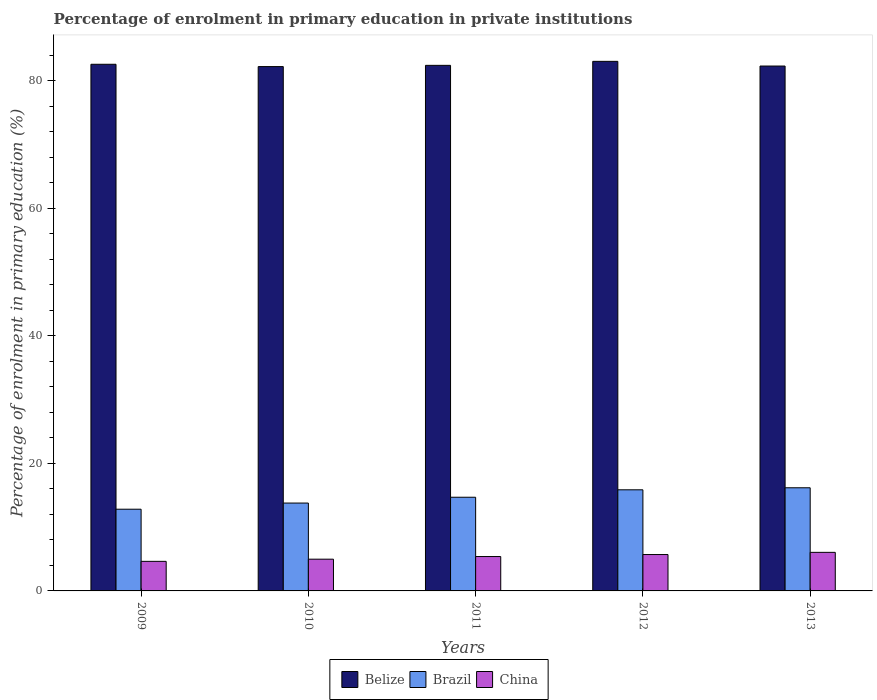How many different coloured bars are there?
Keep it short and to the point. 3. How many bars are there on the 5th tick from the right?
Make the answer very short. 3. In how many cases, is the number of bars for a given year not equal to the number of legend labels?
Ensure brevity in your answer.  0. What is the percentage of enrolment in primary education in Brazil in 2013?
Offer a terse response. 16.17. Across all years, what is the maximum percentage of enrolment in primary education in Brazil?
Your answer should be compact. 16.17. Across all years, what is the minimum percentage of enrolment in primary education in Brazil?
Your answer should be very brief. 12.81. In which year was the percentage of enrolment in primary education in China maximum?
Keep it short and to the point. 2013. In which year was the percentage of enrolment in primary education in Belize minimum?
Your response must be concise. 2010. What is the total percentage of enrolment in primary education in Belize in the graph?
Your response must be concise. 412.55. What is the difference between the percentage of enrolment in primary education in China in 2011 and that in 2013?
Offer a very short reply. -0.65. What is the difference between the percentage of enrolment in primary education in China in 2010 and the percentage of enrolment in primary education in Brazil in 2013?
Your response must be concise. -11.2. What is the average percentage of enrolment in primary education in China per year?
Your response must be concise. 5.35. In the year 2012, what is the difference between the percentage of enrolment in primary education in Brazil and percentage of enrolment in primary education in Belize?
Offer a terse response. -67.18. In how many years, is the percentage of enrolment in primary education in China greater than 32 %?
Offer a terse response. 0. What is the ratio of the percentage of enrolment in primary education in China in 2009 to that in 2011?
Make the answer very short. 0.86. What is the difference between the highest and the second highest percentage of enrolment in primary education in Brazil?
Keep it short and to the point. 0.32. What is the difference between the highest and the lowest percentage of enrolment in primary education in China?
Provide a succinct answer. 1.41. In how many years, is the percentage of enrolment in primary education in China greater than the average percentage of enrolment in primary education in China taken over all years?
Ensure brevity in your answer.  3. Is the sum of the percentage of enrolment in primary education in Brazil in 2009 and 2012 greater than the maximum percentage of enrolment in primary education in China across all years?
Provide a succinct answer. Yes. What does the 1st bar from the left in 2009 represents?
Provide a short and direct response. Belize. What does the 2nd bar from the right in 2013 represents?
Your answer should be very brief. Brazil. Are all the bars in the graph horizontal?
Offer a very short reply. No. What is the difference between two consecutive major ticks on the Y-axis?
Your answer should be compact. 20. Are the values on the major ticks of Y-axis written in scientific E-notation?
Ensure brevity in your answer.  No. Does the graph contain any zero values?
Your response must be concise. No. Does the graph contain grids?
Your response must be concise. No. Where does the legend appear in the graph?
Offer a terse response. Bottom center. What is the title of the graph?
Your answer should be very brief. Percentage of enrolment in primary education in private institutions. What is the label or title of the Y-axis?
Provide a short and direct response. Percentage of enrolment in primary education (%). What is the Percentage of enrolment in primary education (%) in Belize in 2009?
Your answer should be very brief. 82.58. What is the Percentage of enrolment in primary education (%) in Brazil in 2009?
Ensure brevity in your answer.  12.81. What is the Percentage of enrolment in primary education (%) in China in 2009?
Give a very brief answer. 4.64. What is the Percentage of enrolment in primary education (%) of Belize in 2010?
Give a very brief answer. 82.22. What is the Percentage of enrolment in primary education (%) of Brazil in 2010?
Offer a terse response. 13.78. What is the Percentage of enrolment in primary education (%) in China in 2010?
Provide a succinct answer. 4.98. What is the Percentage of enrolment in primary education (%) of Belize in 2011?
Ensure brevity in your answer.  82.41. What is the Percentage of enrolment in primary education (%) in Brazil in 2011?
Offer a terse response. 14.69. What is the Percentage of enrolment in primary education (%) in China in 2011?
Offer a very short reply. 5.39. What is the Percentage of enrolment in primary education (%) of Belize in 2012?
Give a very brief answer. 83.04. What is the Percentage of enrolment in primary education (%) of Brazil in 2012?
Make the answer very short. 15.86. What is the Percentage of enrolment in primary education (%) of China in 2012?
Ensure brevity in your answer.  5.7. What is the Percentage of enrolment in primary education (%) of Belize in 2013?
Offer a terse response. 82.3. What is the Percentage of enrolment in primary education (%) of Brazil in 2013?
Ensure brevity in your answer.  16.17. What is the Percentage of enrolment in primary education (%) of China in 2013?
Your response must be concise. 6.05. Across all years, what is the maximum Percentage of enrolment in primary education (%) in Belize?
Give a very brief answer. 83.04. Across all years, what is the maximum Percentage of enrolment in primary education (%) of Brazil?
Provide a short and direct response. 16.17. Across all years, what is the maximum Percentage of enrolment in primary education (%) of China?
Give a very brief answer. 6.05. Across all years, what is the minimum Percentage of enrolment in primary education (%) in Belize?
Offer a very short reply. 82.22. Across all years, what is the minimum Percentage of enrolment in primary education (%) of Brazil?
Keep it short and to the point. 12.81. Across all years, what is the minimum Percentage of enrolment in primary education (%) of China?
Give a very brief answer. 4.64. What is the total Percentage of enrolment in primary education (%) in Belize in the graph?
Provide a succinct answer. 412.55. What is the total Percentage of enrolment in primary education (%) of Brazil in the graph?
Your answer should be compact. 73.31. What is the total Percentage of enrolment in primary education (%) of China in the graph?
Offer a very short reply. 26.76. What is the difference between the Percentage of enrolment in primary education (%) in Belize in 2009 and that in 2010?
Your answer should be compact. 0.36. What is the difference between the Percentage of enrolment in primary education (%) of Brazil in 2009 and that in 2010?
Give a very brief answer. -0.97. What is the difference between the Percentage of enrolment in primary education (%) in China in 2009 and that in 2010?
Offer a terse response. -0.34. What is the difference between the Percentage of enrolment in primary education (%) in Belize in 2009 and that in 2011?
Offer a terse response. 0.17. What is the difference between the Percentage of enrolment in primary education (%) of Brazil in 2009 and that in 2011?
Provide a succinct answer. -1.88. What is the difference between the Percentage of enrolment in primary education (%) of China in 2009 and that in 2011?
Offer a terse response. -0.76. What is the difference between the Percentage of enrolment in primary education (%) in Belize in 2009 and that in 2012?
Offer a very short reply. -0.46. What is the difference between the Percentage of enrolment in primary education (%) in Brazil in 2009 and that in 2012?
Your answer should be compact. -3.04. What is the difference between the Percentage of enrolment in primary education (%) in China in 2009 and that in 2012?
Make the answer very short. -1.07. What is the difference between the Percentage of enrolment in primary education (%) of Belize in 2009 and that in 2013?
Make the answer very short. 0.28. What is the difference between the Percentage of enrolment in primary education (%) of Brazil in 2009 and that in 2013?
Offer a very short reply. -3.36. What is the difference between the Percentage of enrolment in primary education (%) of China in 2009 and that in 2013?
Ensure brevity in your answer.  -1.41. What is the difference between the Percentage of enrolment in primary education (%) in Belize in 2010 and that in 2011?
Your response must be concise. -0.19. What is the difference between the Percentage of enrolment in primary education (%) in Brazil in 2010 and that in 2011?
Offer a terse response. -0.91. What is the difference between the Percentage of enrolment in primary education (%) in China in 2010 and that in 2011?
Provide a succinct answer. -0.41. What is the difference between the Percentage of enrolment in primary education (%) in Belize in 2010 and that in 2012?
Give a very brief answer. -0.82. What is the difference between the Percentage of enrolment in primary education (%) in Brazil in 2010 and that in 2012?
Give a very brief answer. -2.08. What is the difference between the Percentage of enrolment in primary education (%) of China in 2010 and that in 2012?
Offer a terse response. -0.73. What is the difference between the Percentage of enrolment in primary education (%) of Belize in 2010 and that in 2013?
Offer a very short reply. -0.09. What is the difference between the Percentage of enrolment in primary education (%) of Brazil in 2010 and that in 2013?
Ensure brevity in your answer.  -2.4. What is the difference between the Percentage of enrolment in primary education (%) of China in 2010 and that in 2013?
Ensure brevity in your answer.  -1.07. What is the difference between the Percentage of enrolment in primary education (%) of Belize in 2011 and that in 2012?
Provide a short and direct response. -0.63. What is the difference between the Percentage of enrolment in primary education (%) of Brazil in 2011 and that in 2012?
Your response must be concise. -1.17. What is the difference between the Percentage of enrolment in primary education (%) of China in 2011 and that in 2012?
Your answer should be compact. -0.31. What is the difference between the Percentage of enrolment in primary education (%) in Belize in 2011 and that in 2013?
Provide a short and direct response. 0.11. What is the difference between the Percentage of enrolment in primary education (%) in Brazil in 2011 and that in 2013?
Provide a succinct answer. -1.48. What is the difference between the Percentage of enrolment in primary education (%) of China in 2011 and that in 2013?
Your answer should be very brief. -0.65. What is the difference between the Percentage of enrolment in primary education (%) of Belize in 2012 and that in 2013?
Offer a very short reply. 0.73. What is the difference between the Percentage of enrolment in primary education (%) of Brazil in 2012 and that in 2013?
Offer a terse response. -0.32. What is the difference between the Percentage of enrolment in primary education (%) in China in 2012 and that in 2013?
Provide a short and direct response. -0.34. What is the difference between the Percentage of enrolment in primary education (%) of Belize in 2009 and the Percentage of enrolment in primary education (%) of Brazil in 2010?
Give a very brief answer. 68.8. What is the difference between the Percentage of enrolment in primary education (%) in Belize in 2009 and the Percentage of enrolment in primary education (%) in China in 2010?
Offer a terse response. 77.6. What is the difference between the Percentage of enrolment in primary education (%) of Brazil in 2009 and the Percentage of enrolment in primary education (%) of China in 2010?
Your answer should be compact. 7.83. What is the difference between the Percentage of enrolment in primary education (%) of Belize in 2009 and the Percentage of enrolment in primary education (%) of Brazil in 2011?
Give a very brief answer. 67.89. What is the difference between the Percentage of enrolment in primary education (%) in Belize in 2009 and the Percentage of enrolment in primary education (%) in China in 2011?
Provide a short and direct response. 77.19. What is the difference between the Percentage of enrolment in primary education (%) of Brazil in 2009 and the Percentage of enrolment in primary education (%) of China in 2011?
Keep it short and to the point. 7.42. What is the difference between the Percentage of enrolment in primary education (%) in Belize in 2009 and the Percentage of enrolment in primary education (%) in Brazil in 2012?
Offer a terse response. 66.72. What is the difference between the Percentage of enrolment in primary education (%) of Belize in 2009 and the Percentage of enrolment in primary education (%) of China in 2012?
Your response must be concise. 76.88. What is the difference between the Percentage of enrolment in primary education (%) of Brazil in 2009 and the Percentage of enrolment in primary education (%) of China in 2012?
Provide a succinct answer. 7.11. What is the difference between the Percentage of enrolment in primary education (%) of Belize in 2009 and the Percentage of enrolment in primary education (%) of Brazil in 2013?
Make the answer very short. 66.41. What is the difference between the Percentage of enrolment in primary education (%) in Belize in 2009 and the Percentage of enrolment in primary education (%) in China in 2013?
Make the answer very short. 76.53. What is the difference between the Percentage of enrolment in primary education (%) of Brazil in 2009 and the Percentage of enrolment in primary education (%) of China in 2013?
Your answer should be compact. 6.77. What is the difference between the Percentage of enrolment in primary education (%) in Belize in 2010 and the Percentage of enrolment in primary education (%) in Brazil in 2011?
Offer a terse response. 67.53. What is the difference between the Percentage of enrolment in primary education (%) of Belize in 2010 and the Percentage of enrolment in primary education (%) of China in 2011?
Your answer should be compact. 76.82. What is the difference between the Percentage of enrolment in primary education (%) in Brazil in 2010 and the Percentage of enrolment in primary education (%) in China in 2011?
Make the answer very short. 8.39. What is the difference between the Percentage of enrolment in primary education (%) in Belize in 2010 and the Percentage of enrolment in primary education (%) in Brazil in 2012?
Offer a very short reply. 66.36. What is the difference between the Percentage of enrolment in primary education (%) of Belize in 2010 and the Percentage of enrolment in primary education (%) of China in 2012?
Ensure brevity in your answer.  76.51. What is the difference between the Percentage of enrolment in primary education (%) in Brazil in 2010 and the Percentage of enrolment in primary education (%) in China in 2012?
Provide a short and direct response. 8.07. What is the difference between the Percentage of enrolment in primary education (%) of Belize in 2010 and the Percentage of enrolment in primary education (%) of Brazil in 2013?
Make the answer very short. 66.04. What is the difference between the Percentage of enrolment in primary education (%) of Belize in 2010 and the Percentage of enrolment in primary education (%) of China in 2013?
Ensure brevity in your answer.  76.17. What is the difference between the Percentage of enrolment in primary education (%) in Brazil in 2010 and the Percentage of enrolment in primary education (%) in China in 2013?
Your answer should be compact. 7.73. What is the difference between the Percentage of enrolment in primary education (%) of Belize in 2011 and the Percentage of enrolment in primary education (%) of Brazil in 2012?
Your response must be concise. 66.56. What is the difference between the Percentage of enrolment in primary education (%) in Belize in 2011 and the Percentage of enrolment in primary education (%) in China in 2012?
Give a very brief answer. 76.71. What is the difference between the Percentage of enrolment in primary education (%) in Brazil in 2011 and the Percentage of enrolment in primary education (%) in China in 2012?
Offer a terse response. 8.99. What is the difference between the Percentage of enrolment in primary education (%) in Belize in 2011 and the Percentage of enrolment in primary education (%) in Brazil in 2013?
Ensure brevity in your answer.  66.24. What is the difference between the Percentage of enrolment in primary education (%) of Belize in 2011 and the Percentage of enrolment in primary education (%) of China in 2013?
Offer a very short reply. 76.36. What is the difference between the Percentage of enrolment in primary education (%) in Brazil in 2011 and the Percentage of enrolment in primary education (%) in China in 2013?
Give a very brief answer. 8.64. What is the difference between the Percentage of enrolment in primary education (%) of Belize in 2012 and the Percentage of enrolment in primary education (%) of Brazil in 2013?
Your response must be concise. 66.86. What is the difference between the Percentage of enrolment in primary education (%) in Belize in 2012 and the Percentage of enrolment in primary education (%) in China in 2013?
Give a very brief answer. 76.99. What is the difference between the Percentage of enrolment in primary education (%) of Brazil in 2012 and the Percentage of enrolment in primary education (%) of China in 2013?
Ensure brevity in your answer.  9.81. What is the average Percentage of enrolment in primary education (%) in Belize per year?
Make the answer very short. 82.51. What is the average Percentage of enrolment in primary education (%) in Brazil per year?
Offer a very short reply. 14.66. What is the average Percentage of enrolment in primary education (%) in China per year?
Ensure brevity in your answer.  5.35. In the year 2009, what is the difference between the Percentage of enrolment in primary education (%) of Belize and Percentage of enrolment in primary education (%) of Brazil?
Your answer should be compact. 69.77. In the year 2009, what is the difference between the Percentage of enrolment in primary education (%) in Belize and Percentage of enrolment in primary education (%) in China?
Ensure brevity in your answer.  77.94. In the year 2009, what is the difference between the Percentage of enrolment in primary education (%) of Brazil and Percentage of enrolment in primary education (%) of China?
Your response must be concise. 8.18. In the year 2010, what is the difference between the Percentage of enrolment in primary education (%) in Belize and Percentage of enrolment in primary education (%) in Brazil?
Ensure brevity in your answer.  68.44. In the year 2010, what is the difference between the Percentage of enrolment in primary education (%) in Belize and Percentage of enrolment in primary education (%) in China?
Make the answer very short. 77.24. In the year 2011, what is the difference between the Percentage of enrolment in primary education (%) of Belize and Percentage of enrolment in primary education (%) of Brazil?
Provide a succinct answer. 67.72. In the year 2011, what is the difference between the Percentage of enrolment in primary education (%) in Belize and Percentage of enrolment in primary education (%) in China?
Give a very brief answer. 77.02. In the year 2011, what is the difference between the Percentage of enrolment in primary education (%) in Brazil and Percentage of enrolment in primary education (%) in China?
Make the answer very short. 9.3. In the year 2012, what is the difference between the Percentage of enrolment in primary education (%) in Belize and Percentage of enrolment in primary education (%) in Brazil?
Keep it short and to the point. 67.18. In the year 2012, what is the difference between the Percentage of enrolment in primary education (%) in Belize and Percentage of enrolment in primary education (%) in China?
Your response must be concise. 77.33. In the year 2012, what is the difference between the Percentage of enrolment in primary education (%) in Brazil and Percentage of enrolment in primary education (%) in China?
Your answer should be very brief. 10.15. In the year 2013, what is the difference between the Percentage of enrolment in primary education (%) in Belize and Percentage of enrolment in primary education (%) in Brazil?
Offer a very short reply. 66.13. In the year 2013, what is the difference between the Percentage of enrolment in primary education (%) of Belize and Percentage of enrolment in primary education (%) of China?
Your response must be concise. 76.26. In the year 2013, what is the difference between the Percentage of enrolment in primary education (%) in Brazil and Percentage of enrolment in primary education (%) in China?
Your answer should be very brief. 10.13. What is the ratio of the Percentage of enrolment in primary education (%) in Brazil in 2009 to that in 2010?
Offer a terse response. 0.93. What is the ratio of the Percentage of enrolment in primary education (%) in China in 2009 to that in 2010?
Keep it short and to the point. 0.93. What is the ratio of the Percentage of enrolment in primary education (%) in Belize in 2009 to that in 2011?
Your response must be concise. 1. What is the ratio of the Percentage of enrolment in primary education (%) in Brazil in 2009 to that in 2011?
Keep it short and to the point. 0.87. What is the ratio of the Percentage of enrolment in primary education (%) of China in 2009 to that in 2011?
Offer a very short reply. 0.86. What is the ratio of the Percentage of enrolment in primary education (%) of Brazil in 2009 to that in 2012?
Your response must be concise. 0.81. What is the ratio of the Percentage of enrolment in primary education (%) of China in 2009 to that in 2012?
Ensure brevity in your answer.  0.81. What is the ratio of the Percentage of enrolment in primary education (%) in Brazil in 2009 to that in 2013?
Your response must be concise. 0.79. What is the ratio of the Percentage of enrolment in primary education (%) in China in 2009 to that in 2013?
Your answer should be very brief. 0.77. What is the ratio of the Percentage of enrolment in primary education (%) of Belize in 2010 to that in 2011?
Make the answer very short. 1. What is the ratio of the Percentage of enrolment in primary education (%) of Brazil in 2010 to that in 2011?
Your response must be concise. 0.94. What is the ratio of the Percentage of enrolment in primary education (%) in China in 2010 to that in 2011?
Your response must be concise. 0.92. What is the ratio of the Percentage of enrolment in primary education (%) in Belize in 2010 to that in 2012?
Your answer should be very brief. 0.99. What is the ratio of the Percentage of enrolment in primary education (%) in Brazil in 2010 to that in 2012?
Your answer should be compact. 0.87. What is the ratio of the Percentage of enrolment in primary education (%) in China in 2010 to that in 2012?
Your answer should be compact. 0.87. What is the ratio of the Percentage of enrolment in primary education (%) of Belize in 2010 to that in 2013?
Keep it short and to the point. 1. What is the ratio of the Percentage of enrolment in primary education (%) in Brazil in 2010 to that in 2013?
Ensure brevity in your answer.  0.85. What is the ratio of the Percentage of enrolment in primary education (%) of China in 2010 to that in 2013?
Ensure brevity in your answer.  0.82. What is the ratio of the Percentage of enrolment in primary education (%) in Belize in 2011 to that in 2012?
Your answer should be very brief. 0.99. What is the ratio of the Percentage of enrolment in primary education (%) in Brazil in 2011 to that in 2012?
Keep it short and to the point. 0.93. What is the ratio of the Percentage of enrolment in primary education (%) of China in 2011 to that in 2012?
Make the answer very short. 0.95. What is the ratio of the Percentage of enrolment in primary education (%) of Belize in 2011 to that in 2013?
Your response must be concise. 1. What is the ratio of the Percentage of enrolment in primary education (%) in Brazil in 2011 to that in 2013?
Give a very brief answer. 0.91. What is the ratio of the Percentage of enrolment in primary education (%) in China in 2011 to that in 2013?
Your answer should be compact. 0.89. What is the ratio of the Percentage of enrolment in primary education (%) of Belize in 2012 to that in 2013?
Make the answer very short. 1.01. What is the ratio of the Percentage of enrolment in primary education (%) of Brazil in 2012 to that in 2013?
Provide a succinct answer. 0.98. What is the ratio of the Percentage of enrolment in primary education (%) in China in 2012 to that in 2013?
Provide a short and direct response. 0.94. What is the difference between the highest and the second highest Percentage of enrolment in primary education (%) of Belize?
Your response must be concise. 0.46. What is the difference between the highest and the second highest Percentage of enrolment in primary education (%) of Brazil?
Offer a very short reply. 0.32. What is the difference between the highest and the second highest Percentage of enrolment in primary education (%) in China?
Your response must be concise. 0.34. What is the difference between the highest and the lowest Percentage of enrolment in primary education (%) in Belize?
Give a very brief answer. 0.82. What is the difference between the highest and the lowest Percentage of enrolment in primary education (%) of Brazil?
Offer a terse response. 3.36. What is the difference between the highest and the lowest Percentage of enrolment in primary education (%) in China?
Ensure brevity in your answer.  1.41. 